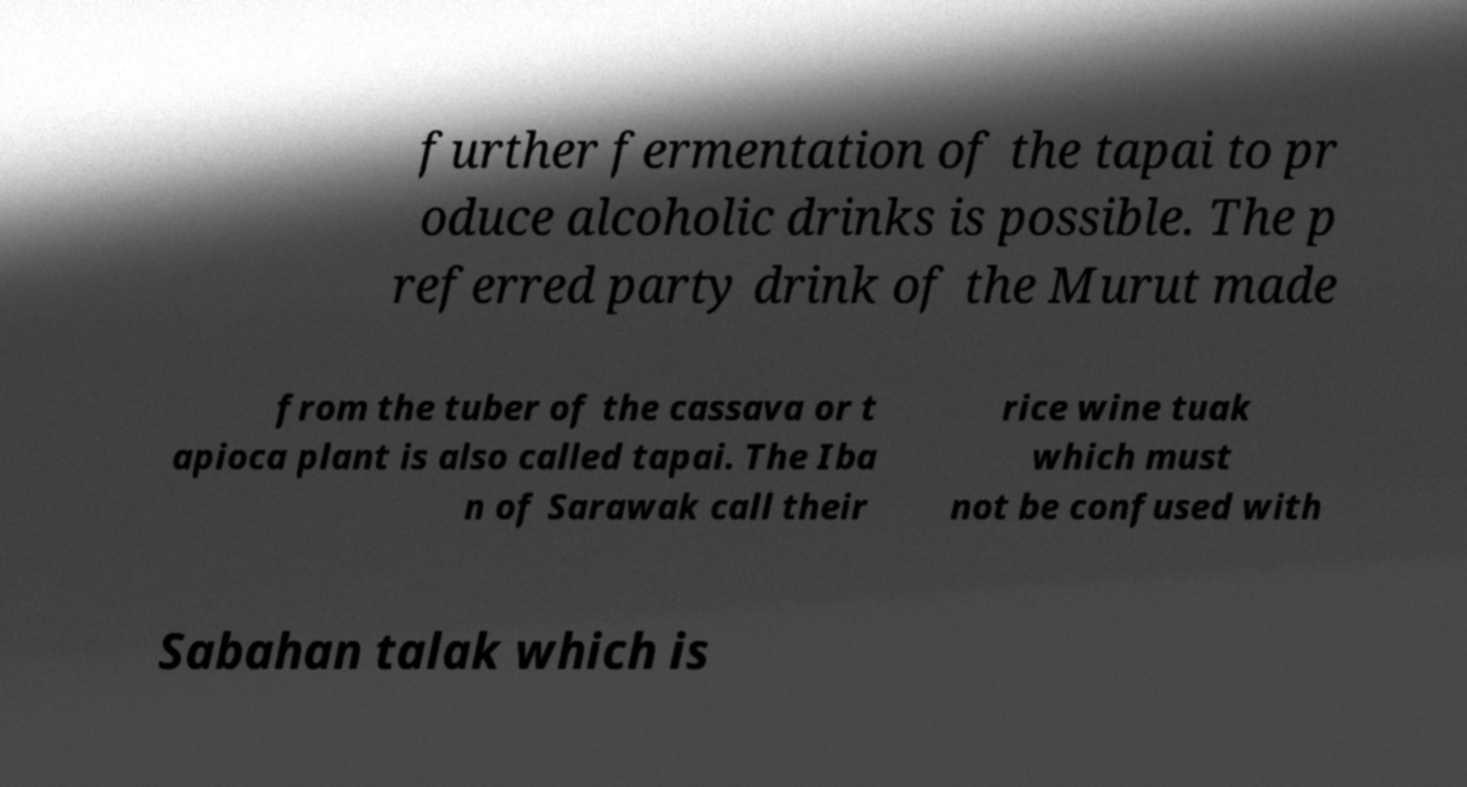Can you accurately transcribe the text from the provided image for me? further fermentation of the tapai to pr oduce alcoholic drinks is possible. The p referred party drink of the Murut made from the tuber of the cassava or t apioca plant is also called tapai. The Iba n of Sarawak call their rice wine tuak which must not be confused with Sabahan talak which is 